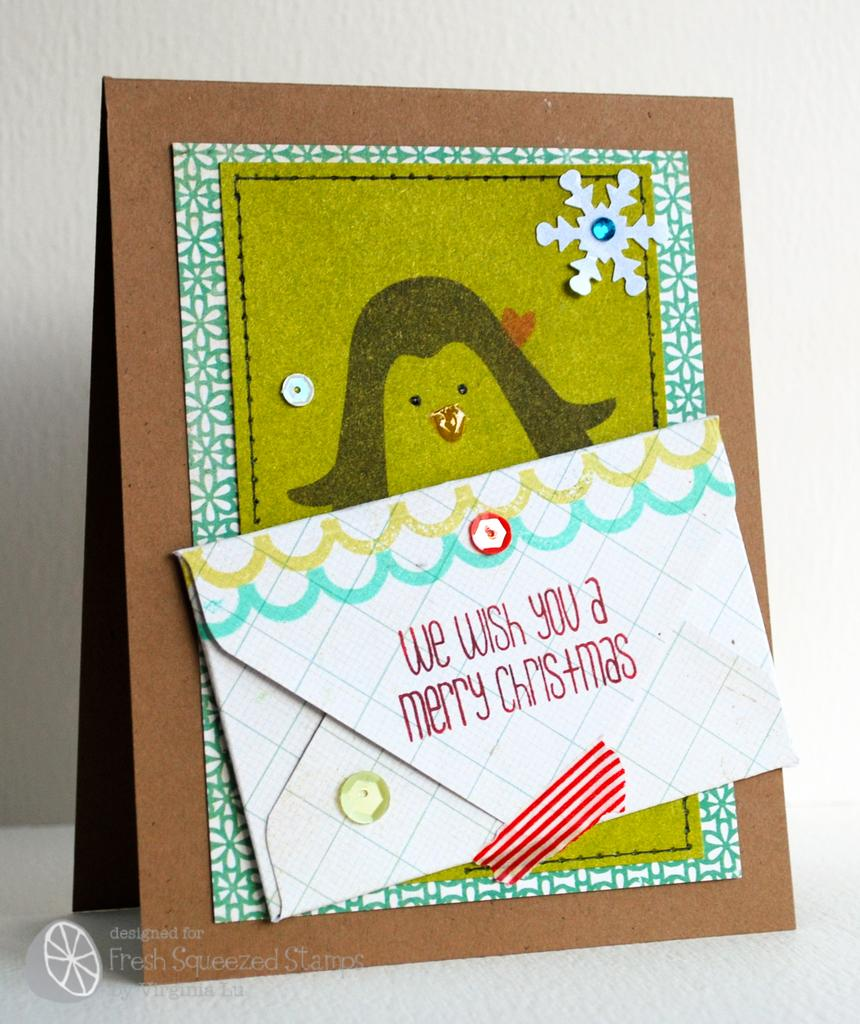<image>
Create a compact narrative representing the image presented. A greeting card with a photo of a penguin and an envelope with the words We Wish You A Merrry Christmas in red 